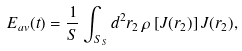<formula> <loc_0><loc_0><loc_500><loc_500>E _ { a v } ( t ) = \frac { 1 } { S } \int _ { S _ { S } } d ^ { 2 } r _ { 2 } \, \rho \left [ J ( r _ { 2 } ) \right ] J ( r _ { 2 } ) ,</formula> 